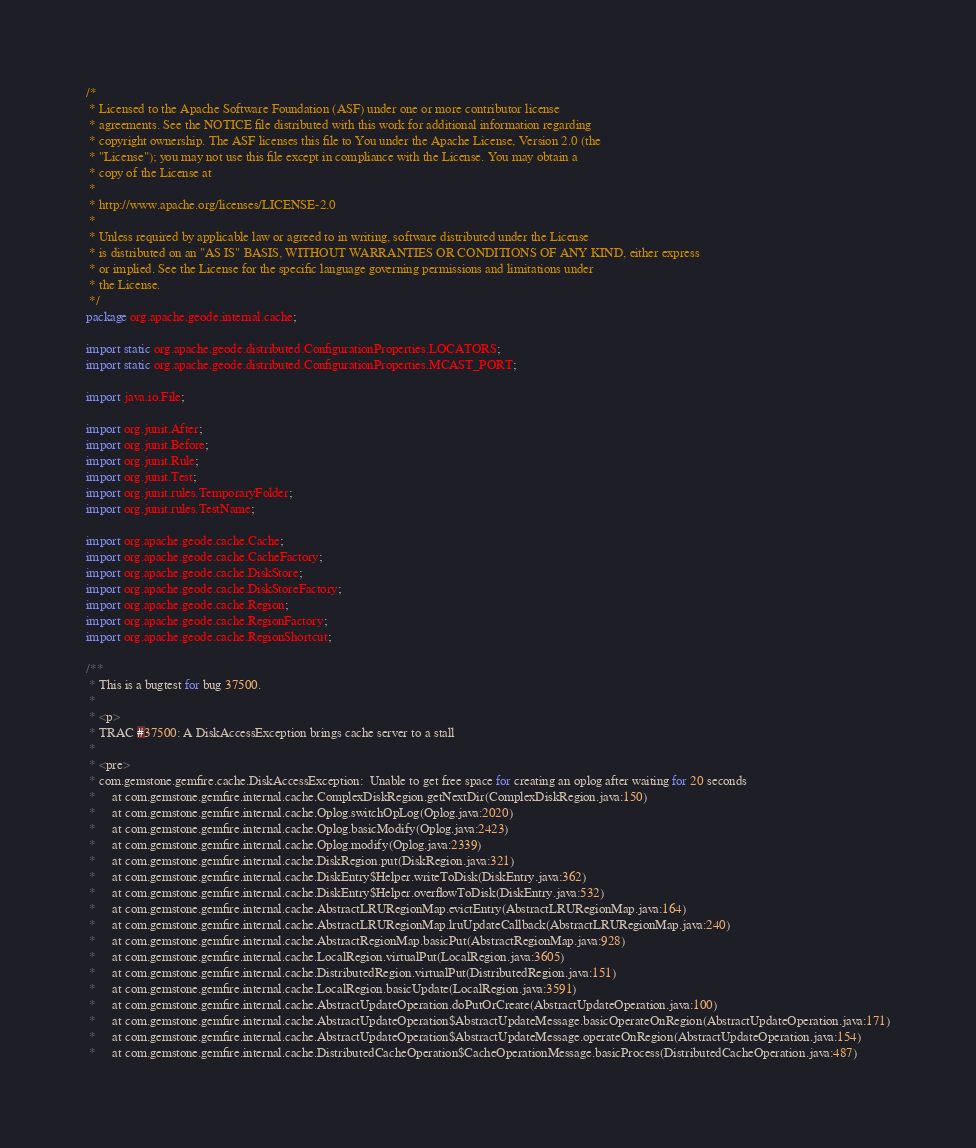Convert code to text. <code><loc_0><loc_0><loc_500><loc_500><_Java_>/*
 * Licensed to the Apache Software Foundation (ASF) under one or more contributor license
 * agreements. See the NOTICE file distributed with this work for additional information regarding
 * copyright ownership. The ASF licenses this file to You under the Apache License, Version 2.0 (the
 * "License"); you may not use this file except in compliance with the License. You may obtain a
 * copy of the License at
 *
 * http://www.apache.org/licenses/LICENSE-2.0
 *
 * Unless required by applicable law or agreed to in writing, software distributed under the License
 * is distributed on an "AS IS" BASIS, WITHOUT WARRANTIES OR CONDITIONS OF ANY KIND, either express
 * or implied. See the License for the specific language governing permissions and limitations under
 * the License.
 */
package org.apache.geode.internal.cache;

import static org.apache.geode.distributed.ConfigurationProperties.LOCATORS;
import static org.apache.geode.distributed.ConfigurationProperties.MCAST_PORT;

import java.io.File;

import org.junit.After;
import org.junit.Before;
import org.junit.Rule;
import org.junit.Test;
import org.junit.rules.TemporaryFolder;
import org.junit.rules.TestName;

import org.apache.geode.cache.Cache;
import org.apache.geode.cache.CacheFactory;
import org.apache.geode.cache.DiskStore;
import org.apache.geode.cache.DiskStoreFactory;
import org.apache.geode.cache.Region;
import org.apache.geode.cache.RegionFactory;
import org.apache.geode.cache.RegionShortcut;

/**
 * This is a bugtest for bug 37500.
 *
 * <p>
 * TRAC #37500: A DiskAccessException brings cache server to a stall
 *
 * <pre>
 * com.gemstone.gemfire.cache.DiskAccessException:  Unable to get free space for creating an oplog after waiting for 20 seconds
 *     at com.gemstone.gemfire.internal.cache.ComplexDiskRegion.getNextDir(ComplexDiskRegion.java:150)
 *     at com.gemstone.gemfire.internal.cache.Oplog.switchOpLog(Oplog.java:2020)
 *     at com.gemstone.gemfire.internal.cache.Oplog.basicModify(Oplog.java:2423)
 *     at com.gemstone.gemfire.internal.cache.Oplog.modify(Oplog.java:2339)
 *     at com.gemstone.gemfire.internal.cache.DiskRegion.put(DiskRegion.java:321)
 *     at com.gemstone.gemfire.internal.cache.DiskEntry$Helper.writeToDisk(DiskEntry.java:362)
 *     at com.gemstone.gemfire.internal.cache.DiskEntry$Helper.overflowToDisk(DiskEntry.java:532)
 *     at com.gemstone.gemfire.internal.cache.AbstractLRURegionMap.evictEntry(AbstractLRURegionMap.java:164)
 *     at com.gemstone.gemfire.internal.cache.AbstractLRURegionMap.lruUpdateCallback(AbstractLRURegionMap.java:240)
 *     at com.gemstone.gemfire.internal.cache.AbstractRegionMap.basicPut(AbstractRegionMap.java:928)
 *     at com.gemstone.gemfire.internal.cache.LocalRegion.virtualPut(LocalRegion.java:3605)
 *     at com.gemstone.gemfire.internal.cache.DistributedRegion.virtualPut(DistributedRegion.java:151)
 *     at com.gemstone.gemfire.internal.cache.LocalRegion.basicUpdate(LocalRegion.java:3591)
 *     at com.gemstone.gemfire.internal.cache.AbstractUpdateOperation.doPutOrCreate(AbstractUpdateOperation.java:100)
 *     at com.gemstone.gemfire.internal.cache.AbstractUpdateOperation$AbstractUpdateMessage.basicOperateOnRegion(AbstractUpdateOperation.java:171)
 *     at com.gemstone.gemfire.internal.cache.AbstractUpdateOperation$AbstractUpdateMessage.operateOnRegion(AbstractUpdateOperation.java:154)
 *     at com.gemstone.gemfire.internal.cache.DistributedCacheOperation$CacheOperationMessage.basicProcess(DistributedCacheOperation.java:487)</code> 